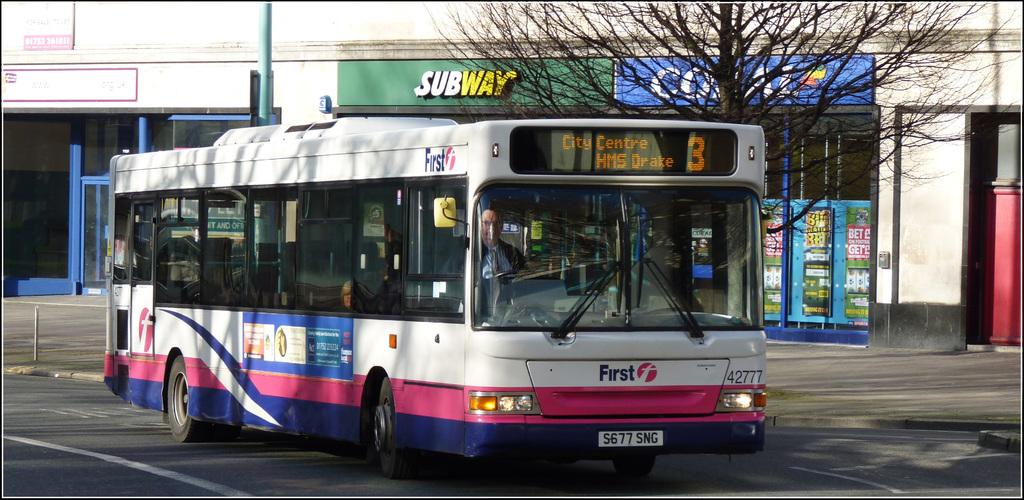<image>
Describe the image concisely. a colorful bus number 3 for Centre HMS Drake 